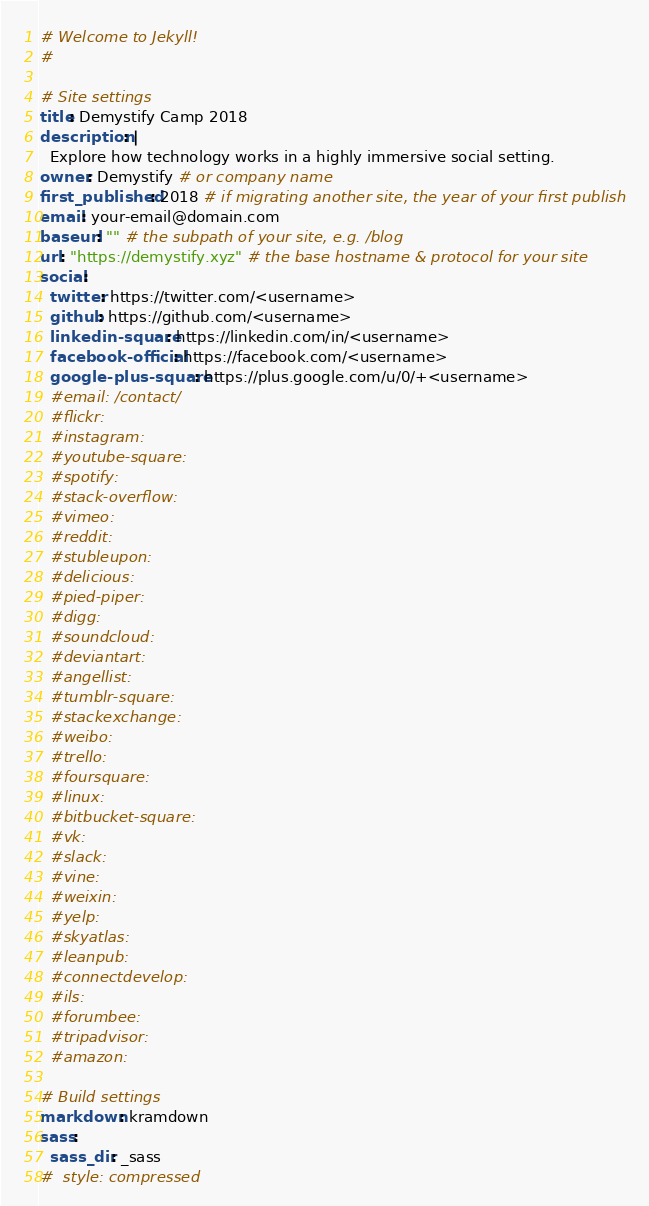Convert code to text. <code><loc_0><loc_0><loc_500><loc_500><_YAML_># Welcome to Jekyll!
#

# Site settings
title: Demystify Camp 2018
description: |
  Explore how technology works in a highly immersive social setting.
owner: Demystify # or company name
first_published: 2018 # if migrating another site, the year of your first publish
email: your-email@domain.com
baseurl: "" # the subpath of your site, e.g. /blog
url: "https://demystify.xyz" # the base hostname & protocol for your site
social:
  twitter: https://twitter.com/<username>
  github: https://github.com/<username>
  linkedin-square: https://linkedin.com/in/<username>
  facebook-official: https://facebook.com/<username>
  google-plus-square: https://plus.google.com/u/0/+<username>
  #email: /contact/
  #flickr:
  #instagram:
  #youtube-square:
  #spotify:
  #stack-overflow:
  #vimeo:
  #reddit:
  #stubleupon:
  #delicious:
  #pied-piper:
  #digg:
  #soundcloud:
  #deviantart:
  #angellist:
  #tumblr-square:
  #stackexchange:
  #weibo:
  #trello:
  #foursquare:
  #linux:
  #bitbucket-square:
  #vk:
  #slack:
  #vine:
  #weixin:
  #yelp:
  #skyatlas:
  #leanpub:
  #connectdevelop:
  #ils:
  #forumbee:
  #tripadvisor:
  #amazon:

# Build settings
markdown: kramdown
sass:
  sass_dir: _sass
#  style: compressed
</code> 